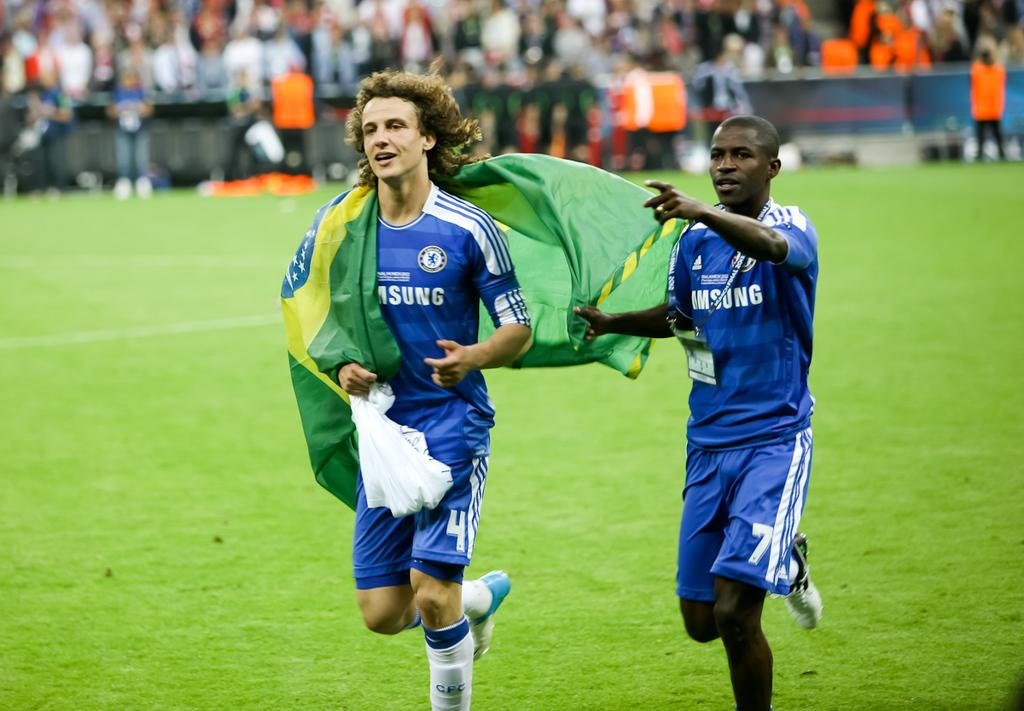<image>
Relay a brief, clear account of the picture shown. Two football players wearing blue sponsored by Samsung. 